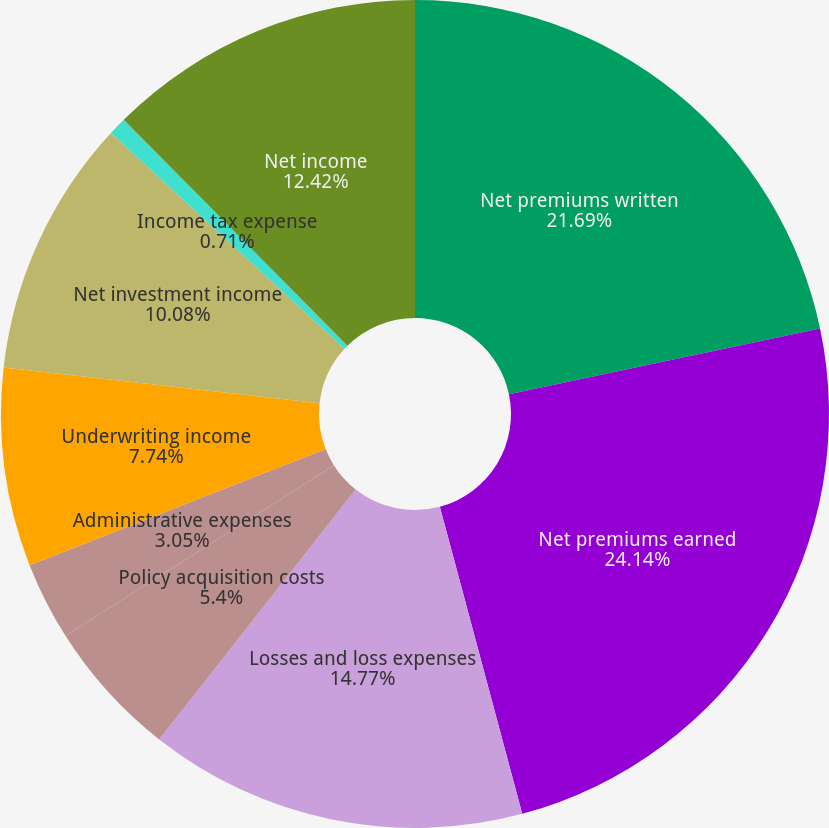Convert chart to OTSL. <chart><loc_0><loc_0><loc_500><loc_500><pie_chart><fcel>Net premiums written<fcel>Net premiums earned<fcel>Losses and loss expenses<fcel>Policy acquisition costs<fcel>Administrative expenses<fcel>Underwriting income<fcel>Net investment income<fcel>Income tax expense<fcel>Net income<nl><fcel>21.69%<fcel>24.14%<fcel>14.77%<fcel>5.4%<fcel>3.05%<fcel>7.74%<fcel>10.08%<fcel>0.71%<fcel>12.42%<nl></chart> 